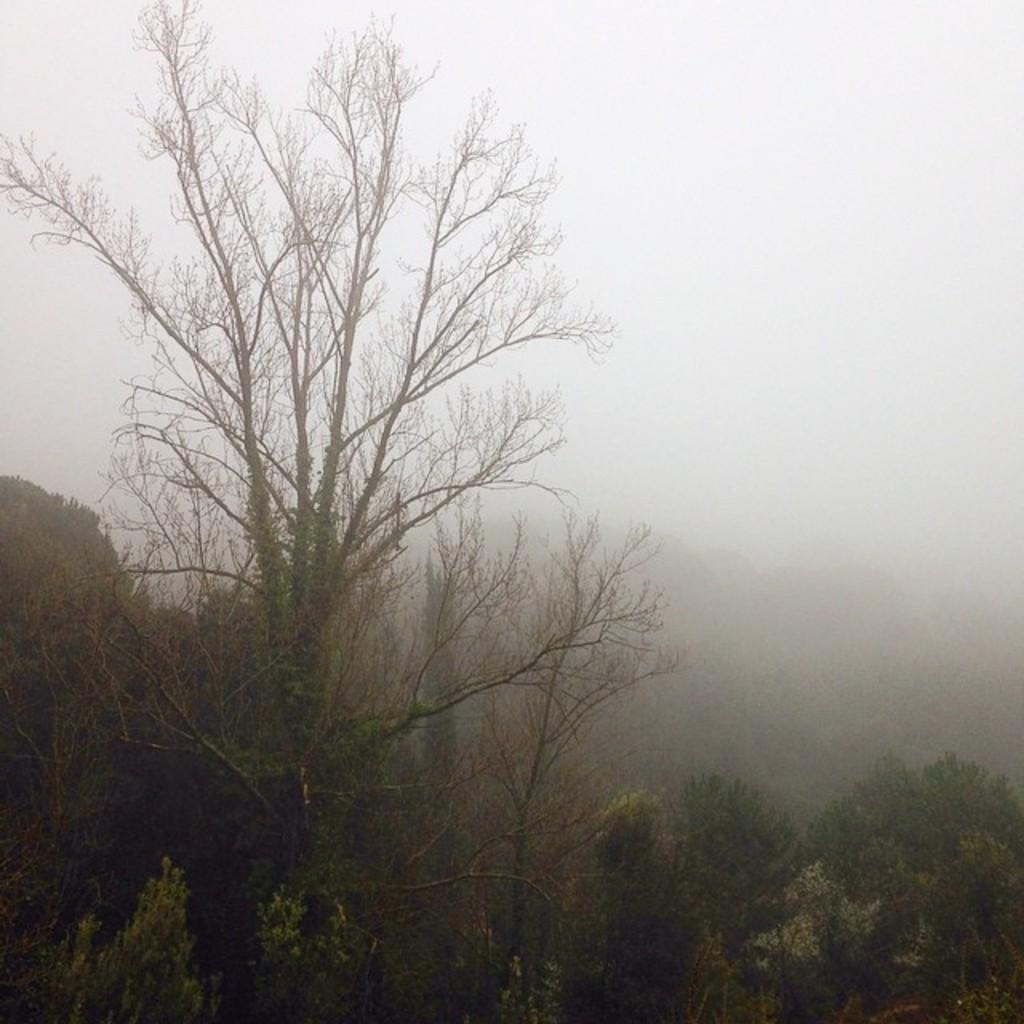Could you give a brief overview of what you see in this image? In this picture we can see few trees and blurry background. 